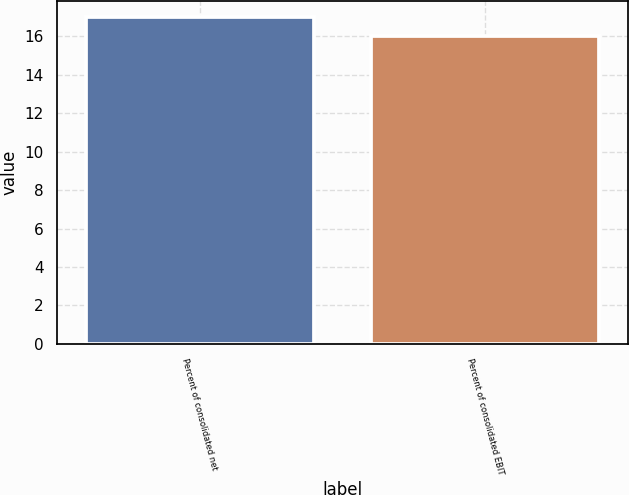Convert chart. <chart><loc_0><loc_0><loc_500><loc_500><bar_chart><fcel>Percent of consolidated net<fcel>Percent of consolidated EBIT<nl><fcel>17<fcel>16<nl></chart> 